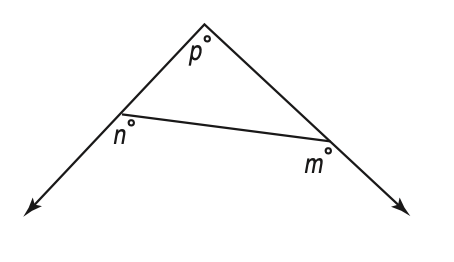Question: In the figure at the right, what is the value of p in terms of m and n?
Choices:
A. 360 - (m - n)
B. m + n + 180
C. m + n - 180
D. m - n + 360
Answer with the letter. Answer: C 